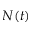<formula> <loc_0><loc_0><loc_500><loc_500>N ( t )</formula> 